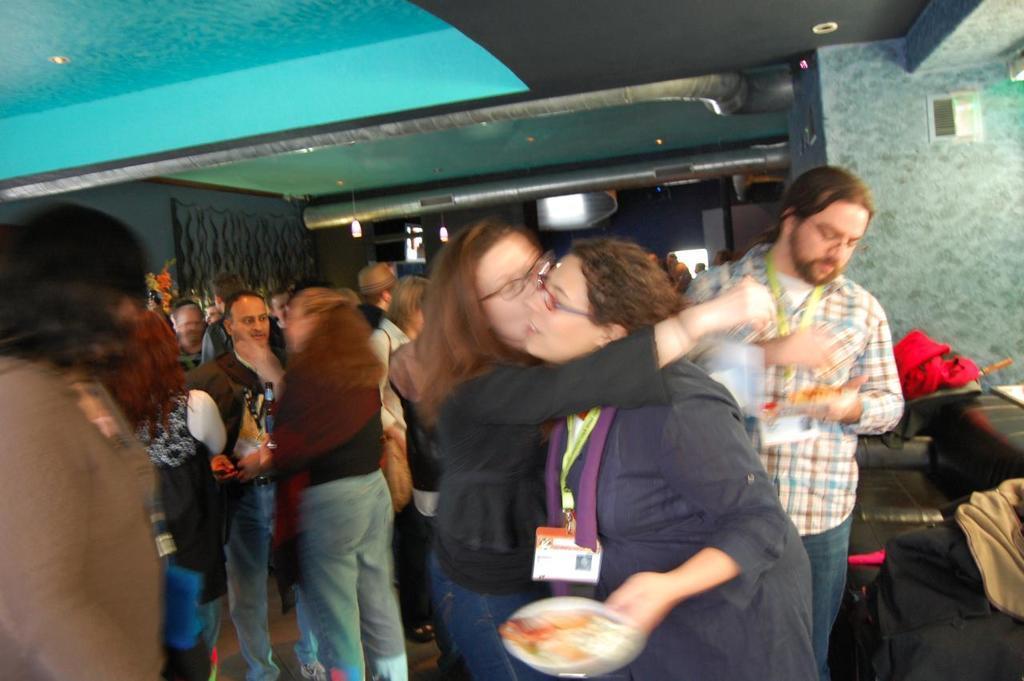Can you describe this image briefly? In the center of the image we can see many persons standing on the floor holding plates and beverage bottles. On the right side of the image we can see sofa and clothes. In the background we can see flowers, persons, windows, lights and door. 